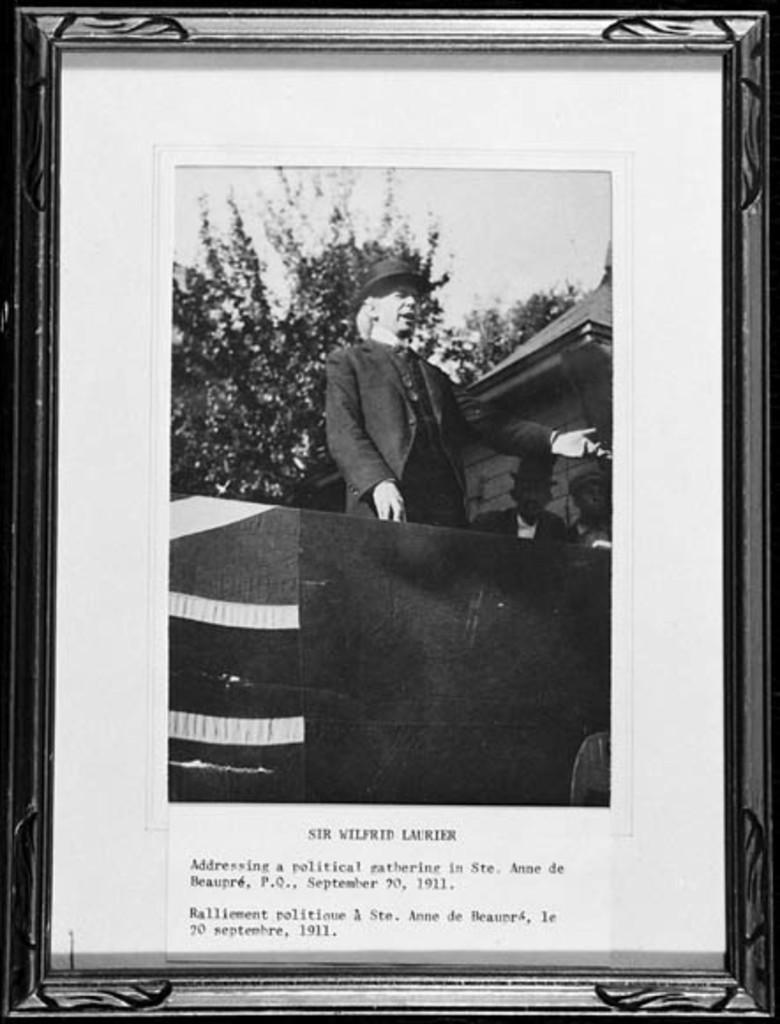<image>
Share a concise interpretation of the image provided. Photograph of Sir Wilfrid Laurier giving a speech in the year 1911. 